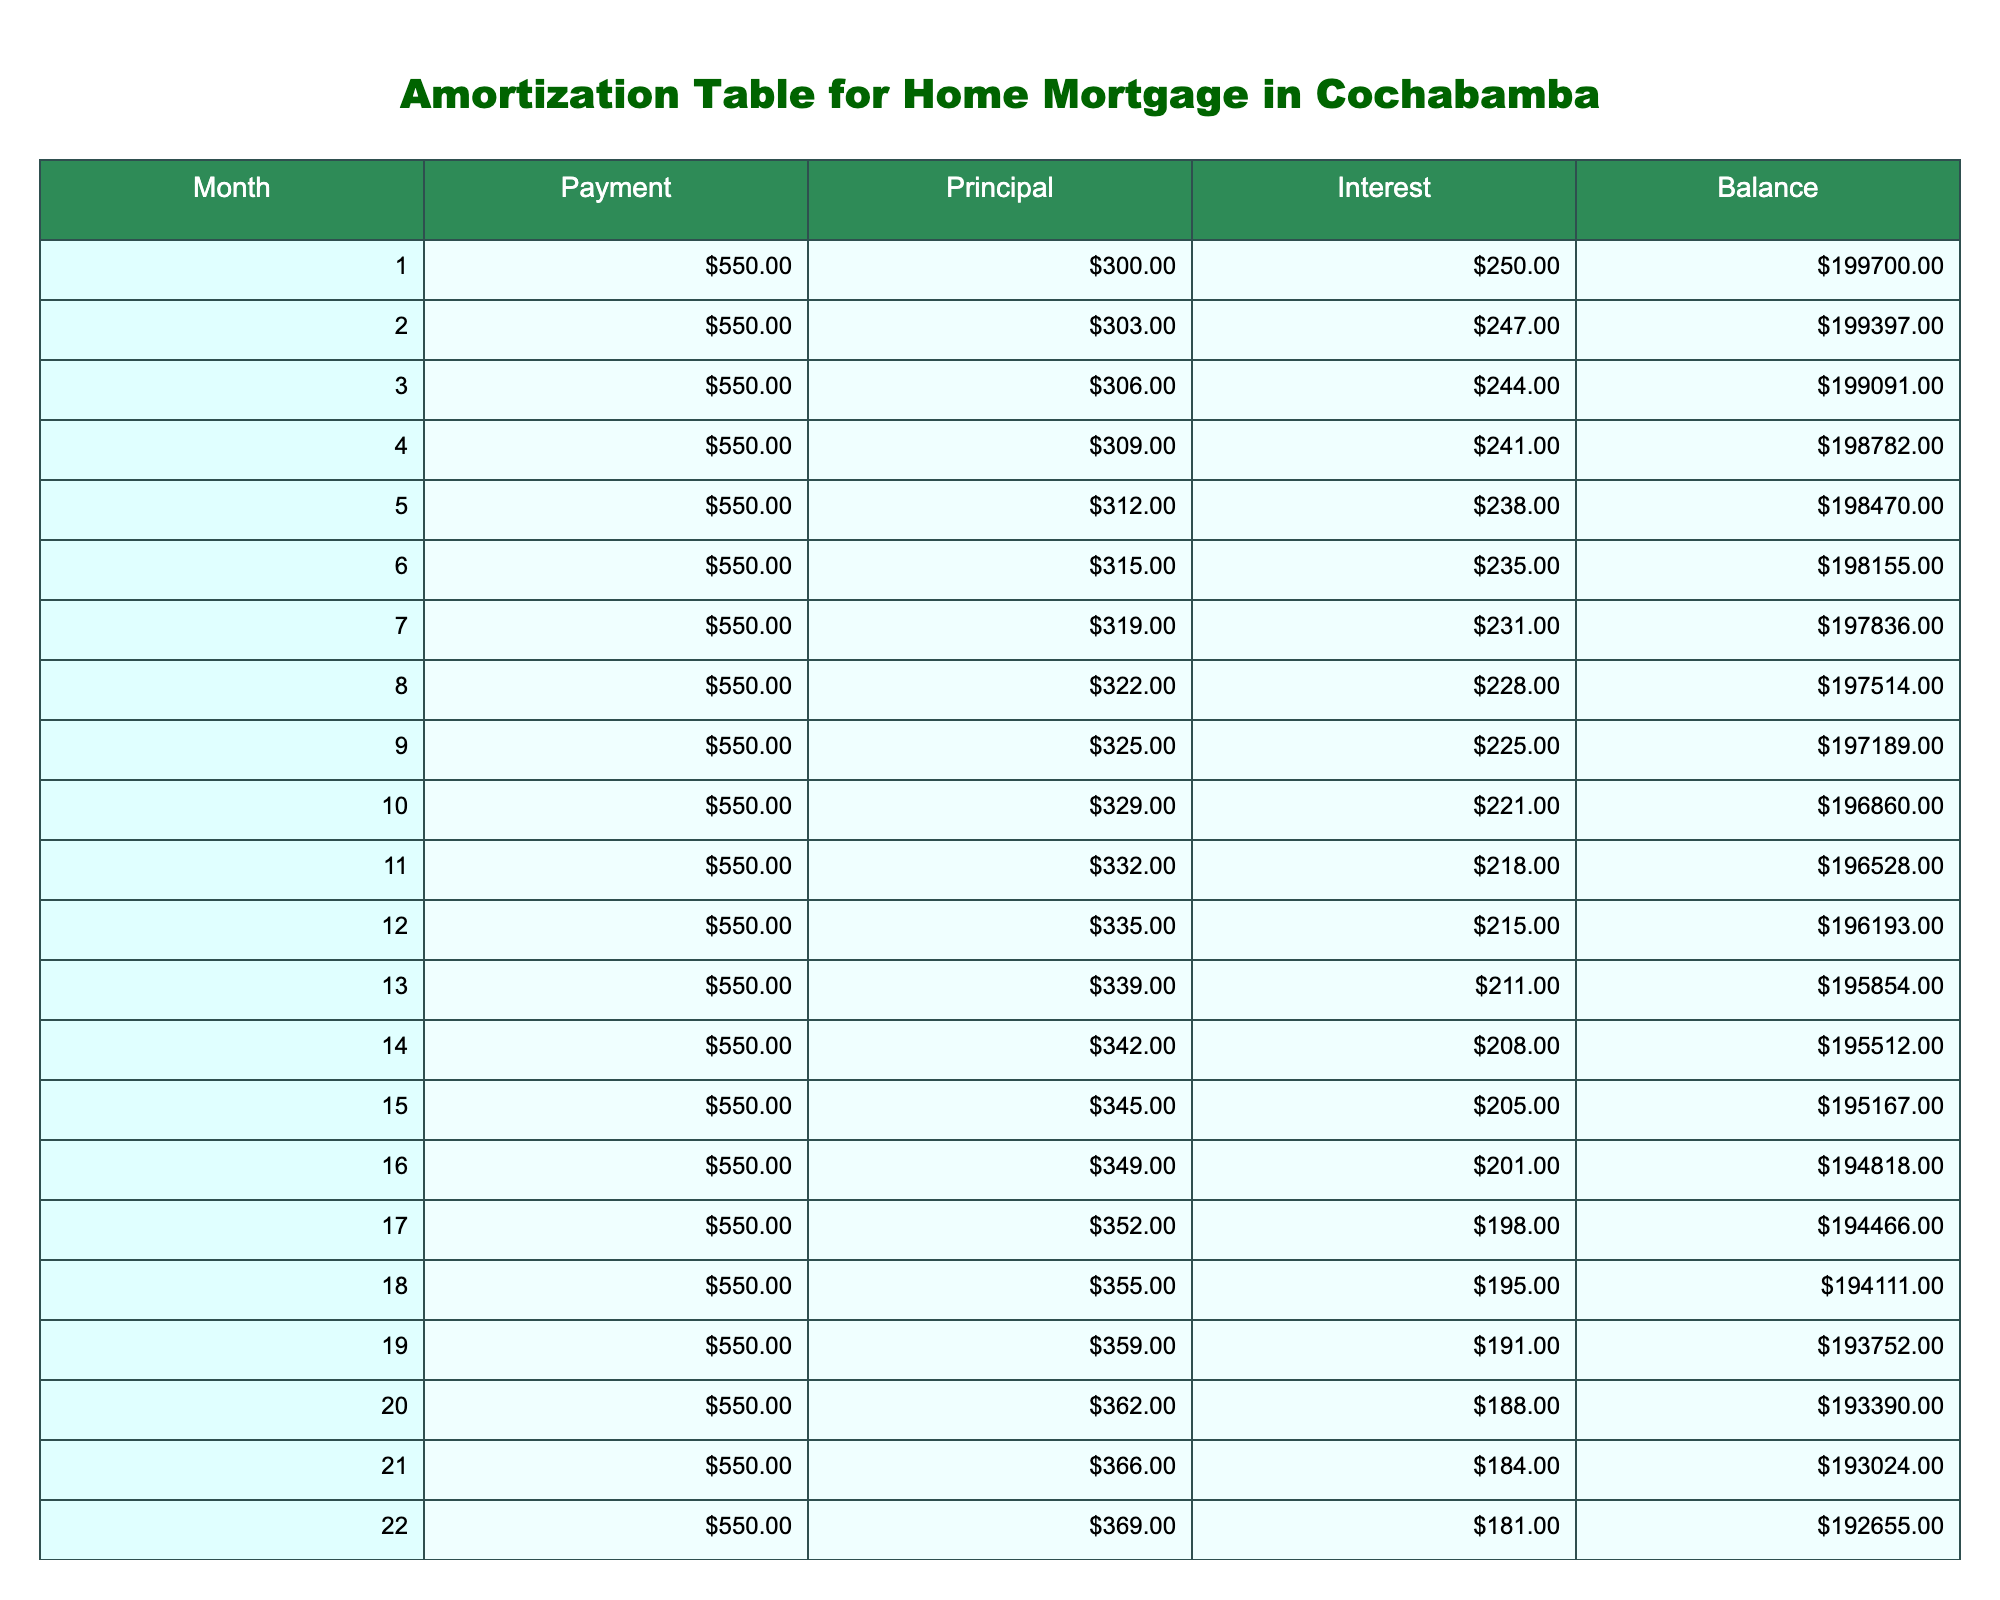What is the payment amount for the first month? The table shows that for Month 1, the Payment amount is listed as 550.00. Thus, this value can be retrieved directly from the table.
Answer: 550.00 What is the balance after the 12th month? According to the table data for Month 12, the Balance is recorded as 196193.00. This can be directly referenced from the table.
Answer: 196193.00 What is the total principal paid in the first 6 months? To find the total principal paid in the first 6 months, we add the Principal values for these months: 300.00 + 303.00 + 306.00 + 309.00 + 312.00 + 315.00 = 1845.00. This calculation provides the total principal over the specified period.
Answer: 1845.00 Is the interest payment decreasing over the first 24 months? The data shows that the Interest payments are: 250.00, 247.00, 244.00, 241.00, 238.00, 235.00, and so on. These amounts decrease consistently, confirming that the interest payments are decreasing.
Answer: Yes What is the difference in balance between month 1 and month 24? The balance in Month 1 is 199700.00 and the balance in Month 24 is 191906.00. To find the difference, we subtract the balance in Month 24 from Month 1: 199700.00 - 191906.00 = 794.00. This shows how much the balance has reduced over that period.
Answer: 794.00 What was the average monthly interest payment for the first year? To calculate the average interest paid in the first year, sum the Interest values for the first 12 months: 250.00 + 247.00 + 244.00 + 241.00 + 238.00 + 235.00 + 231.00 + 228.00 + 225.00 + 221.00 + 218.00 + 215.00 = 2766.00. Then, divide by the number of months (12): 2766.00 / 12 = 230.50. This gives us the average monthly interest for that year.
Answer: 230.50 How much was the principal paid in the 15th month? From the table, the Principal amount for Month 15 is shown as 345.00. This value can be found directly in the table as the specific month is referred.
Answer: 345.00 What is the cumulative principal paid by month 10? To determine the cumulative principal paid by Month 10, we sum the first 10 Principal entries: 300.00 + 303.00 + 306.00 + 309.00 + 312.00 + 315.00 + 319.00 + 322.00 + 325.00 + 329.00 = 2960.00. This total reflects all principal payments made across these 10 months.
Answer: 2960.00 